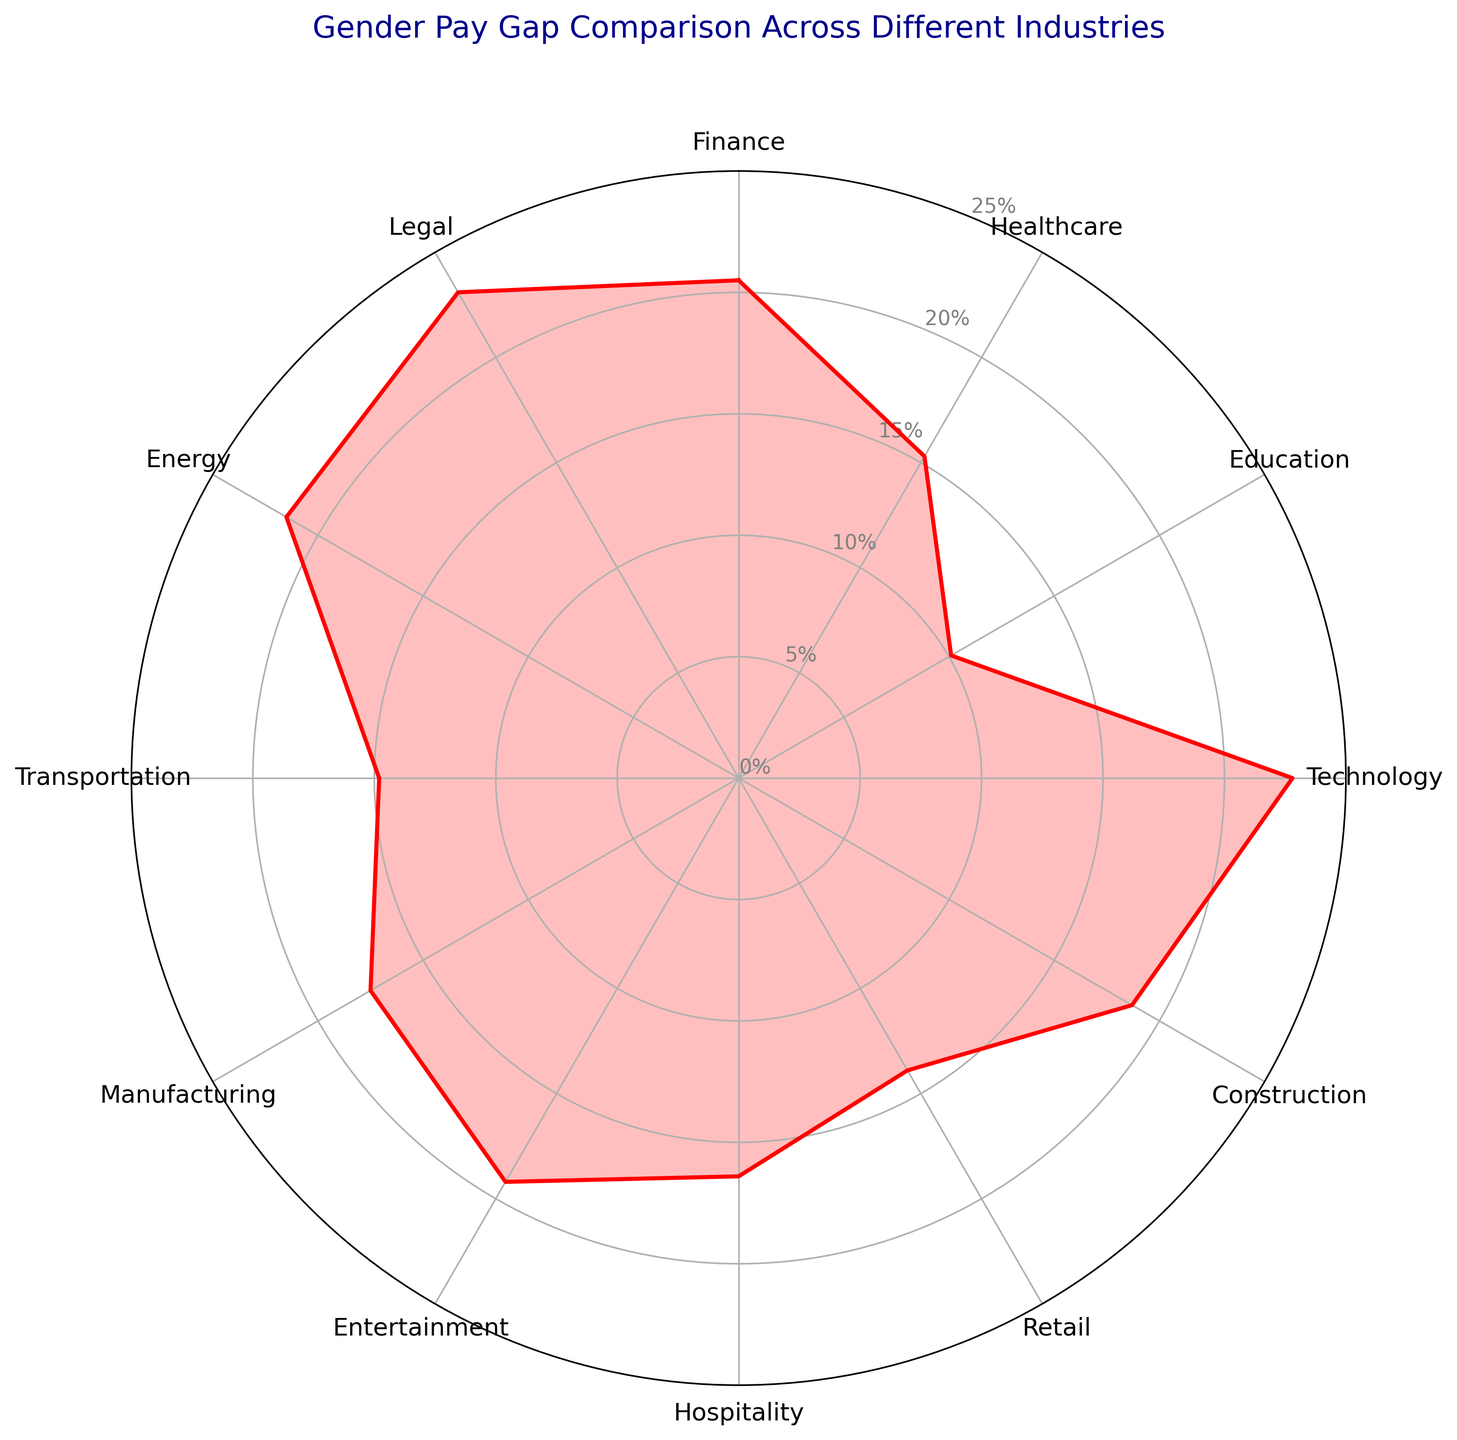Which industry has the highest gender pay gap? By examining the radar chart, the highest point represents the industry with the highest gender pay gap. The highest point is for the Legal industry at 23.1%.
Answer: Legal Which industry has the lowest gender pay gap? Looking at the radar chart, the lowest point represents the industry with the lowest gender pay gap. The lowest point is for Education at 10.1%.
Answer: Education What is the difference in gender pay gap between the Legal and Education industries? The gender pay gap for the Legal industry is 23.1% and for the Education industry, it is 10.1%. The difference is 23.1% - 10.1% = 13%.
Answer: 13% Which industries have a gender pay gap greater than 20%? Observing the radar chart, the industries with data points above 20% are Finance (20.5%), Technology (22.8%), Energy (21.5%), and Legal (23.1%).
Answer: Finance, Technology, Energy, Legal Of Energy, Manufacturing, and Transportation, which has the smallest gender pay gap? Checking each of the data points for these industries, Energy is at 21.5%, Manufacturing at 17.5%, and Transportation at 14.8%. The smallest among these is Transportation.
Answer: Transportation How does the gender pay gap in the Healthcare industry compare to the Retail industry? From the radar chart, the Healthcare industry has a pay gap of 15.3% and the Retail industry has a pay gap of 13.9%. The Healthcare industry has a higher gender pay gap than Retail by 1.4%.
Answer: Healthcare is 1.4% higher What is the average gender pay gap across all industries? Sum of gender pay gaps: 20.5 + 15.3 + 10.1 + 22.8 + 18.7 + 13.9 + 16.4 + 19.2 + 17.5 + 14.8 + 21.5 + 23.1 = 213.8. Number of industries: 12. Average = 213.8 / 12 = 17.82%.
Answer: 17.82% Among the top three industries with the highest gender pay gaps, which is the second highest? The top three industries are Legal (23.1%), Technology (22.8%), and Energy (21.5%). The second highest is Technology with 22.8%.
Answer: Technology Which has a greater gender pay gap, Hospitality or Entertainment? According to the radar chart, Hospitality has a gender pay gap of 16.4% and Entertainment has 19.2%. Therefore, Entertainment has a greater gender pay gap.
Answer: Entertainment 